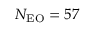Convert formula to latex. <formula><loc_0><loc_0><loc_500><loc_500>N _ { E O } = 5 7</formula> 